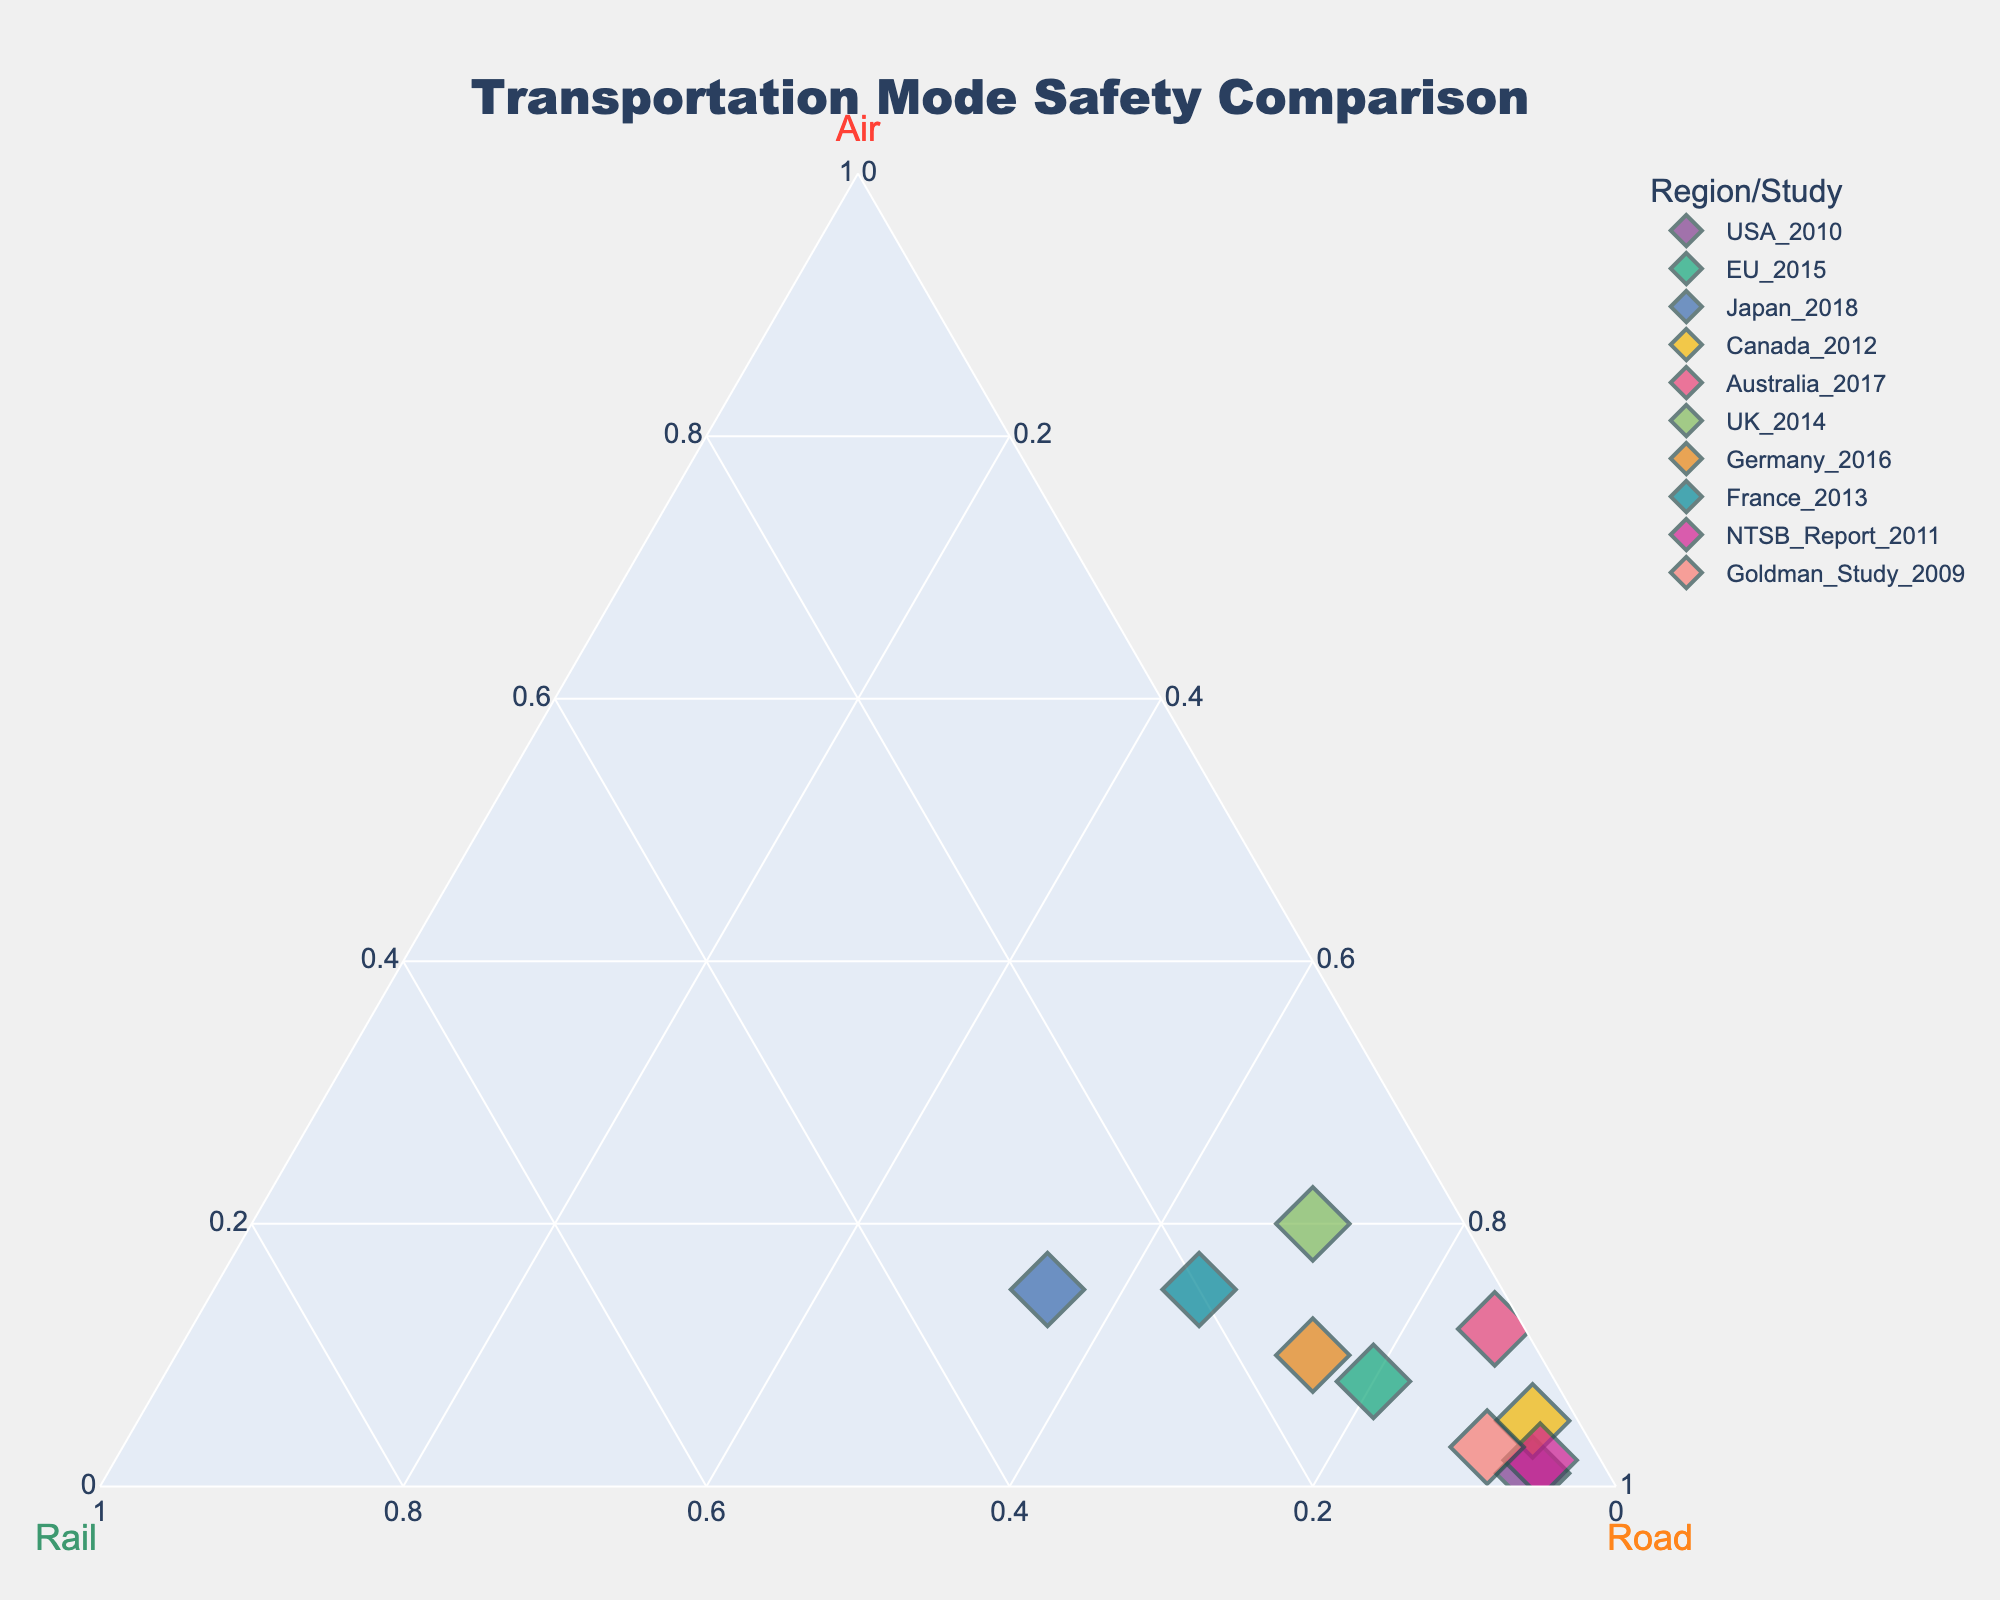What's the title of the figure? The title of the figure is located at the top and is often the largest text. By observing the figure, we can identify the title.
Answer: "Transportation Mode Safety Comparison" How many data points are represented in the figure? Count the number of distinct markers on the plot. Each marker represents one data point.
Answer: 10 What is the proportion of air travel safety for the UK in 2014? Find the marker labeled "UK_2014" and look at its position relative to the "Air" axis. It indicates the air travel proportion.
Answer: 0.20 Which study or region has the highest proportion dedicated to rail transport? Look for the marker closest to the "Rail" axis peak. This indicates the highest rail transport proportion.
Answer: Japan_2018 Are there any regions/studies with the same proportion for air travel? If so, which ones? Compare the air travel proportions (values along the "Air" axis) and find if any are identical.
Answer: France_2013 and Japan_2018 both have 0.15 Which regions/studies show a dominant preference for road travel (above 90%)? Identify markers closely situated near the "Road" apex, then check the labels to confirm if their road travel proportions are above 0.90.
Answer: USA_2010, Canada_2012, NTSB_Report_2011 For the data point with the highest air travel proportion, what are the proportions for rail and road? Locate the marker with the highest air travel value and then check its positions on the "Rail" and "Road" axes.
Answer: Rail: 0.10, Road: 0.70 (UK_2014) What's the average proportion of air travel across all regions/studies? Sum all air travel proportions and divide by the number of data points. The air travel proportions are 0.01, 0.08, 0.15, 0.05, 0.12, 0.20, 0.10, 0.15, 0.02, 0.03. Their sum is 0.91. The average is 0.91/10 = 0.091.
Answer: 0.091 Which region/study has an equal or almost equal distribution between rail and road transport? Identify markers roughly equidistant from the "Rail" and "Road" axes. The one closest to such a balance will have nearly equal rail and road proportions.
Answer: France_2013 (Rail: 0.20, Road: 0.65) Compare Germany_2016 and Goldman_Study_2009 in terms of road travel safety. Which one has a higher proportion? Compare the positions of Germany_2016 and Goldman_Study_2009 markers in relation to the “Road” axis.
Answer: Germany_2016 (0.75) > Goldman_Study_2009 (0.90) 